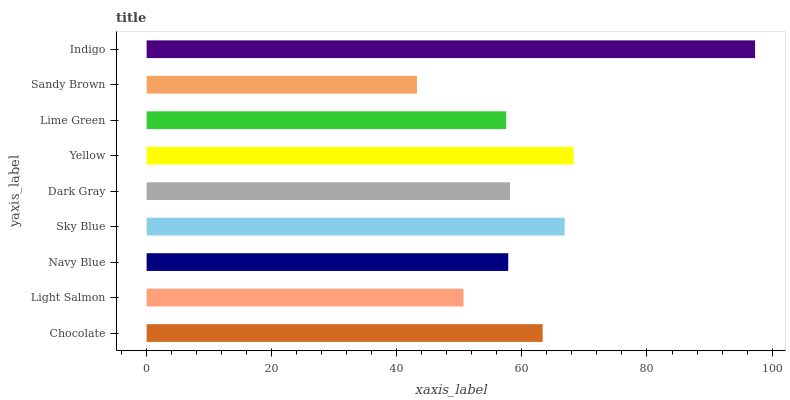Is Sandy Brown the minimum?
Answer yes or no. Yes. Is Indigo the maximum?
Answer yes or no. Yes. Is Light Salmon the minimum?
Answer yes or no. No. Is Light Salmon the maximum?
Answer yes or no. No. Is Chocolate greater than Light Salmon?
Answer yes or no. Yes. Is Light Salmon less than Chocolate?
Answer yes or no. Yes. Is Light Salmon greater than Chocolate?
Answer yes or no. No. Is Chocolate less than Light Salmon?
Answer yes or no. No. Is Dark Gray the high median?
Answer yes or no. Yes. Is Dark Gray the low median?
Answer yes or no. Yes. Is Indigo the high median?
Answer yes or no. No. Is Sandy Brown the low median?
Answer yes or no. No. 